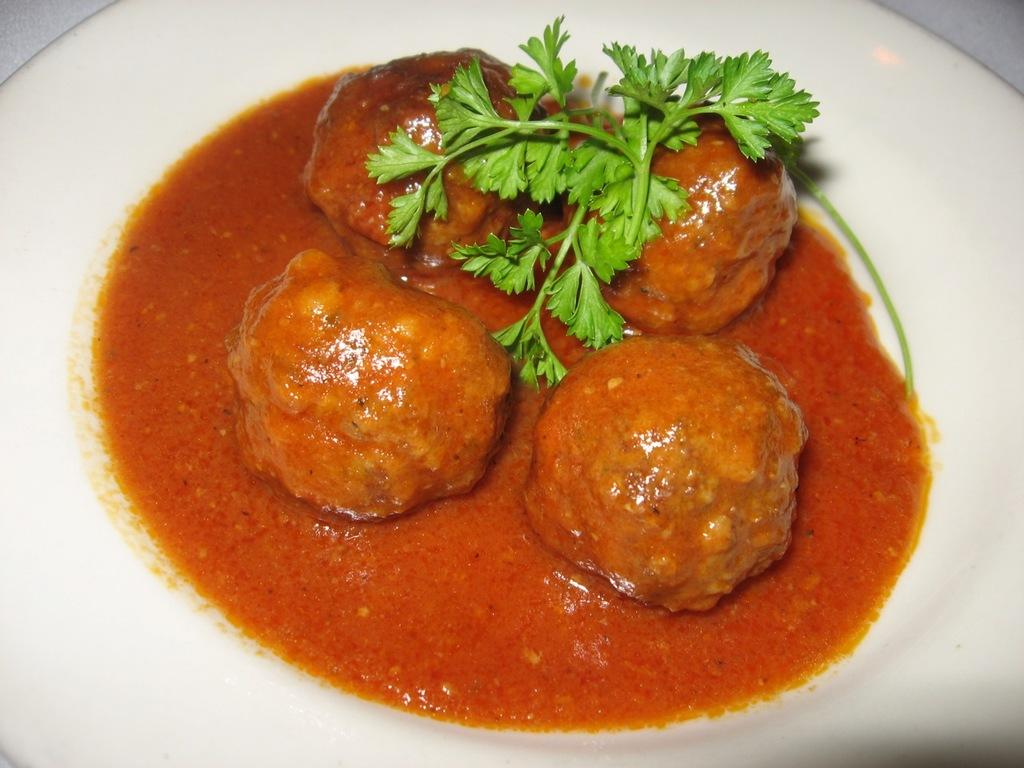What is on the plate that is visible in the image? The plate contains food items. Are there any additional elements on the plate besides the food items? Yes, leaves are present on the plate. How many chairs can be seen around the plate in the image? There are no chairs visible in the image; it only shows a plate with food items and leaves. 